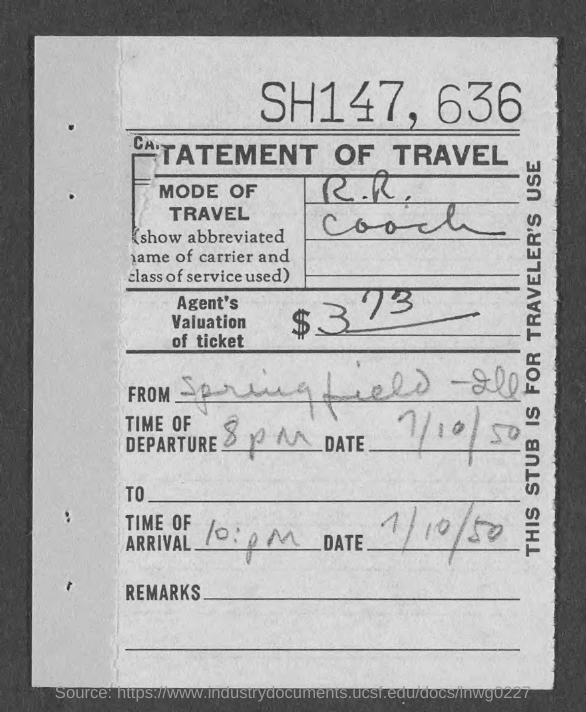Point out several critical features in this image. The currency is XYZ dollars. The value of the agent's ticket is 373 dollars. The time of departure is 8 pm. The date is July 10th, 1950. 